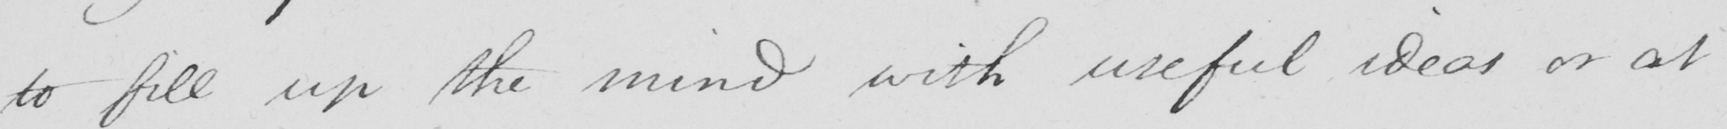What is written in this line of handwriting? to fill up the mind with useful ideas or at 